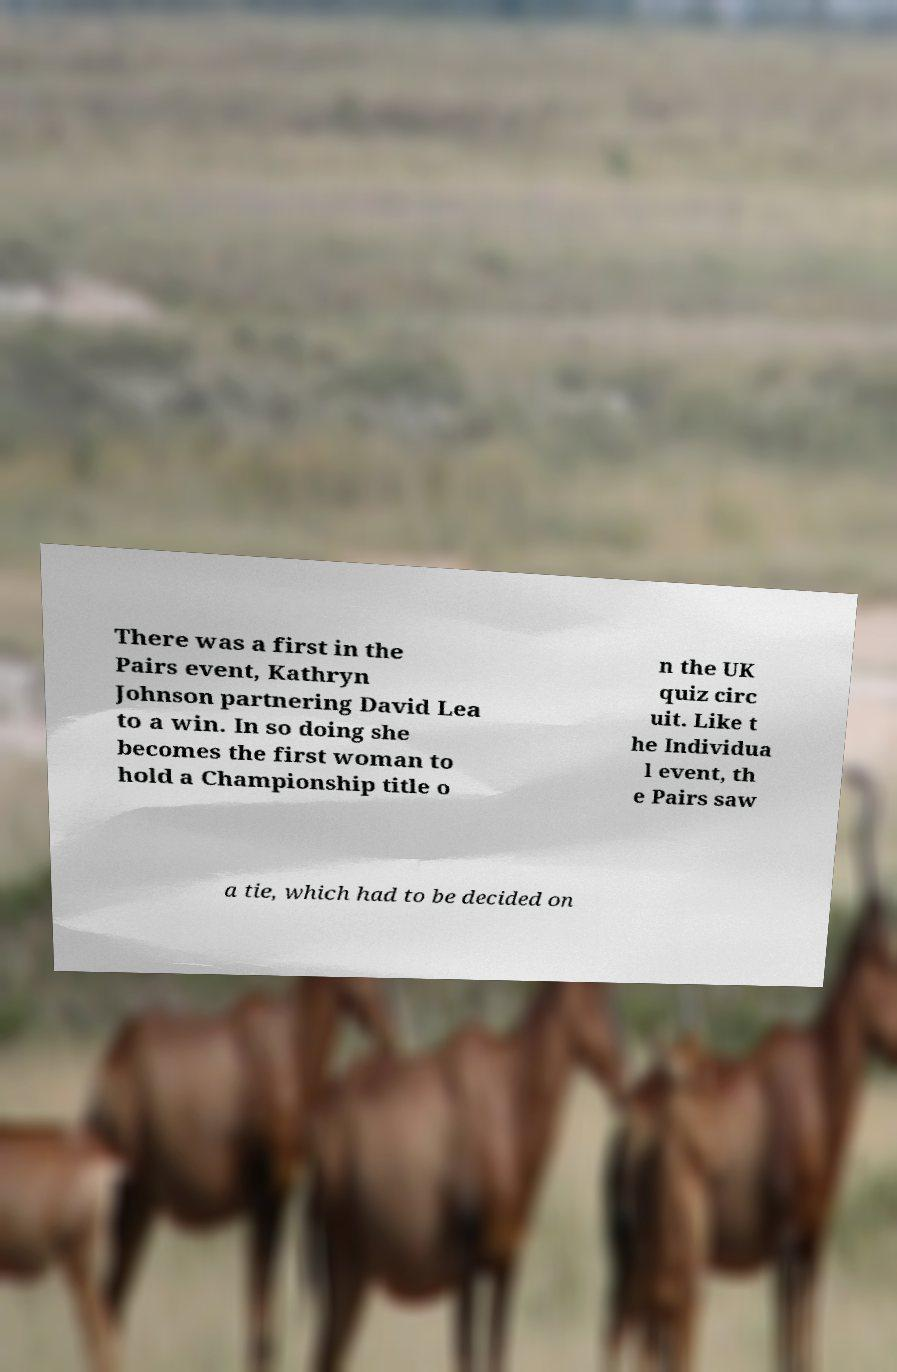For documentation purposes, I need the text within this image transcribed. Could you provide that? There was a first in the Pairs event, Kathryn Johnson partnering David Lea to a win. In so doing she becomes the first woman to hold a Championship title o n the UK quiz circ uit. Like t he Individua l event, th e Pairs saw a tie, which had to be decided on 